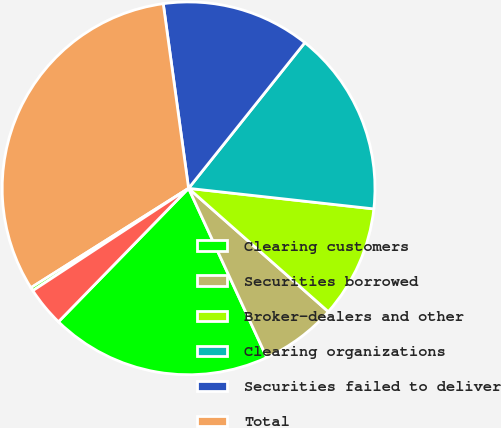<chart> <loc_0><loc_0><loc_500><loc_500><pie_chart><fcel>Clearing customers<fcel>Securities borrowed<fcel>Broker-dealers and other<fcel>Clearing organizations<fcel>Securities failed to deliver<fcel>Total<fcel>Securities loaned<fcel>Securities failed to receive<nl><fcel>19.19%<fcel>6.6%<fcel>9.75%<fcel>16.04%<fcel>12.89%<fcel>31.78%<fcel>0.3%<fcel>3.45%<nl></chart> 